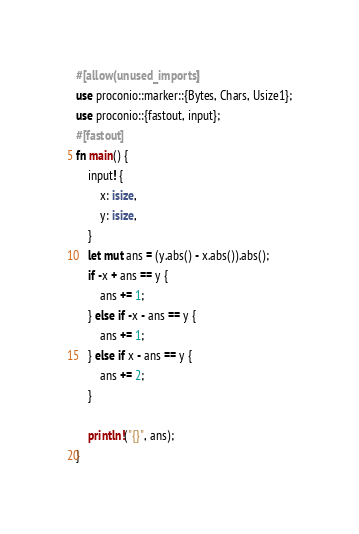<code> <loc_0><loc_0><loc_500><loc_500><_Rust_>#[allow(unused_imports)]
use proconio::marker::{Bytes, Chars, Usize1};
use proconio::{fastout, input};
#[fastout]
fn main() {
    input! {
        x: isize,
        y: isize,
    }
    let mut ans = (y.abs() - x.abs()).abs();
    if -x + ans == y {
        ans += 1;
    } else if -x - ans == y {
        ans += 1;
    } else if x - ans == y {
        ans += 2;
    }

    println!("{}", ans);
}
</code> 